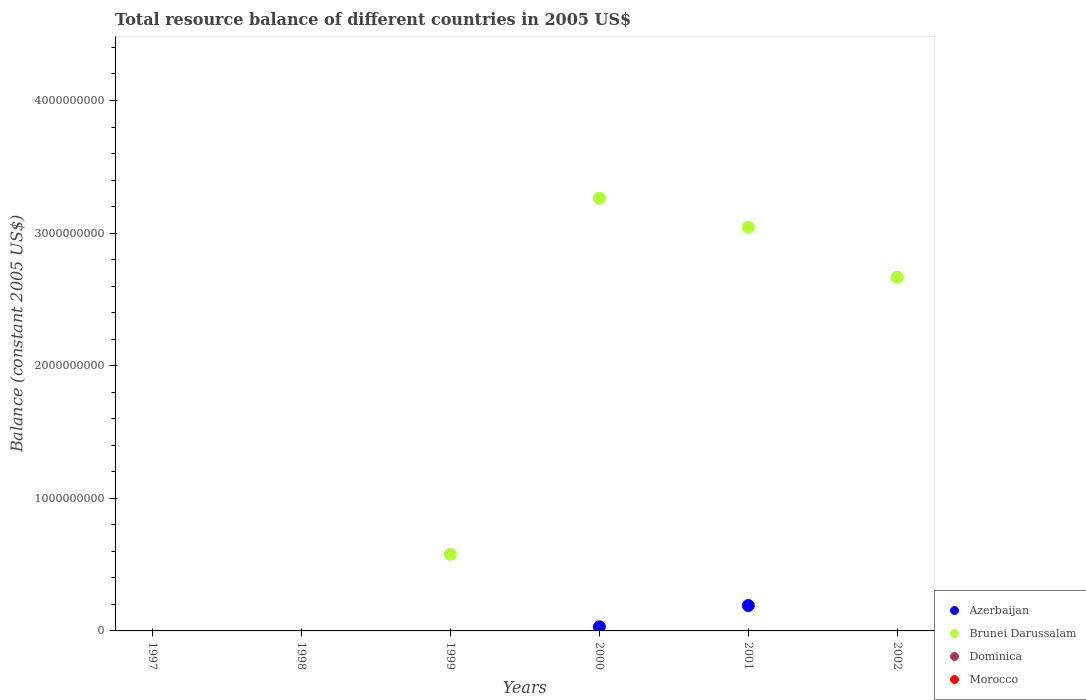How many different coloured dotlines are there?
Your answer should be compact. 2. Is the number of dotlines equal to the number of legend labels?
Provide a short and direct response. No. Across all years, what is the maximum total resource balance in Azerbaijan?
Offer a very short reply. 1.92e+08. Across all years, what is the minimum total resource balance in Azerbaijan?
Provide a short and direct response. 0. In which year was the total resource balance in Azerbaijan maximum?
Make the answer very short. 2001. What is the total total resource balance in Azerbaijan in the graph?
Keep it short and to the point. 2.23e+08. What is the difference between the total resource balance in Brunei Darussalam in 1999 and that in 2002?
Offer a terse response. -2.09e+09. What is the average total resource balance in Azerbaijan per year?
Provide a succinct answer. 3.72e+07. In how many years, is the total resource balance in Dominica greater than 3000000000 US$?
Keep it short and to the point. 0. What is the ratio of the total resource balance in Brunei Darussalam in 1999 to that in 2000?
Provide a succinct answer. 0.18. Is the total resource balance in Brunei Darussalam in 1999 less than that in 2002?
Your answer should be very brief. Yes. What is the difference between the highest and the lowest total resource balance in Brunei Darussalam?
Make the answer very short. 3.26e+09. In how many years, is the total resource balance in Morocco greater than the average total resource balance in Morocco taken over all years?
Provide a succinct answer. 0. Is it the case that in every year, the sum of the total resource balance in Azerbaijan and total resource balance in Brunei Darussalam  is greater than the total resource balance in Morocco?
Offer a very short reply. No. Is the total resource balance in Dominica strictly less than the total resource balance in Morocco over the years?
Give a very brief answer. No. How many dotlines are there?
Provide a succinct answer. 2. What is the difference between two consecutive major ticks on the Y-axis?
Provide a short and direct response. 1.00e+09. Does the graph contain any zero values?
Offer a very short reply. Yes. Does the graph contain grids?
Provide a succinct answer. No. How many legend labels are there?
Give a very brief answer. 4. What is the title of the graph?
Provide a short and direct response. Total resource balance of different countries in 2005 US$. Does "Low & middle income" appear as one of the legend labels in the graph?
Your answer should be very brief. No. What is the label or title of the Y-axis?
Ensure brevity in your answer.  Balance (constant 2005 US$). What is the Balance (constant 2005 US$) of Azerbaijan in 1997?
Your response must be concise. 0. What is the Balance (constant 2005 US$) in Dominica in 1997?
Make the answer very short. 0. What is the Balance (constant 2005 US$) in Dominica in 1998?
Give a very brief answer. 0. What is the Balance (constant 2005 US$) in Morocco in 1998?
Your answer should be very brief. 0. What is the Balance (constant 2005 US$) in Azerbaijan in 1999?
Ensure brevity in your answer.  0. What is the Balance (constant 2005 US$) in Brunei Darussalam in 1999?
Provide a succinct answer. 5.78e+08. What is the Balance (constant 2005 US$) in Dominica in 1999?
Keep it short and to the point. 0. What is the Balance (constant 2005 US$) in Azerbaijan in 2000?
Ensure brevity in your answer.  3.13e+07. What is the Balance (constant 2005 US$) of Brunei Darussalam in 2000?
Your answer should be very brief. 3.26e+09. What is the Balance (constant 2005 US$) in Azerbaijan in 2001?
Your answer should be compact. 1.92e+08. What is the Balance (constant 2005 US$) in Brunei Darussalam in 2001?
Your answer should be compact. 3.04e+09. What is the Balance (constant 2005 US$) of Azerbaijan in 2002?
Ensure brevity in your answer.  0. What is the Balance (constant 2005 US$) of Brunei Darussalam in 2002?
Your answer should be compact. 2.67e+09. What is the Balance (constant 2005 US$) in Dominica in 2002?
Your answer should be compact. 0. What is the Balance (constant 2005 US$) of Morocco in 2002?
Your answer should be very brief. 0. Across all years, what is the maximum Balance (constant 2005 US$) of Azerbaijan?
Provide a short and direct response. 1.92e+08. Across all years, what is the maximum Balance (constant 2005 US$) of Brunei Darussalam?
Your answer should be very brief. 3.26e+09. Across all years, what is the minimum Balance (constant 2005 US$) in Brunei Darussalam?
Your response must be concise. 0. What is the total Balance (constant 2005 US$) in Azerbaijan in the graph?
Keep it short and to the point. 2.23e+08. What is the total Balance (constant 2005 US$) of Brunei Darussalam in the graph?
Ensure brevity in your answer.  9.55e+09. What is the difference between the Balance (constant 2005 US$) of Brunei Darussalam in 1999 and that in 2000?
Make the answer very short. -2.68e+09. What is the difference between the Balance (constant 2005 US$) in Brunei Darussalam in 1999 and that in 2001?
Provide a succinct answer. -2.47e+09. What is the difference between the Balance (constant 2005 US$) in Brunei Darussalam in 1999 and that in 2002?
Your response must be concise. -2.09e+09. What is the difference between the Balance (constant 2005 US$) of Azerbaijan in 2000 and that in 2001?
Your answer should be very brief. -1.60e+08. What is the difference between the Balance (constant 2005 US$) of Brunei Darussalam in 2000 and that in 2001?
Give a very brief answer. 2.19e+08. What is the difference between the Balance (constant 2005 US$) in Brunei Darussalam in 2000 and that in 2002?
Your response must be concise. 5.95e+08. What is the difference between the Balance (constant 2005 US$) of Brunei Darussalam in 2001 and that in 2002?
Your answer should be compact. 3.76e+08. What is the difference between the Balance (constant 2005 US$) in Azerbaijan in 2000 and the Balance (constant 2005 US$) in Brunei Darussalam in 2001?
Keep it short and to the point. -3.01e+09. What is the difference between the Balance (constant 2005 US$) of Azerbaijan in 2000 and the Balance (constant 2005 US$) of Brunei Darussalam in 2002?
Keep it short and to the point. -2.64e+09. What is the difference between the Balance (constant 2005 US$) in Azerbaijan in 2001 and the Balance (constant 2005 US$) in Brunei Darussalam in 2002?
Your answer should be compact. -2.48e+09. What is the average Balance (constant 2005 US$) in Azerbaijan per year?
Ensure brevity in your answer.  3.72e+07. What is the average Balance (constant 2005 US$) in Brunei Darussalam per year?
Make the answer very short. 1.59e+09. What is the average Balance (constant 2005 US$) of Morocco per year?
Your answer should be very brief. 0. In the year 2000, what is the difference between the Balance (constant 2005 US$) of Azerbaijan and Balance (constant 2005 US$) of Brunei Darussalam?
Keep it short and to the point. -3.23e+09. In the year 2001, what is the difference between the Balance (constant 2005 US$) of Azerbaijan and Balance (constant 2005 US$) of Brunei Darussalam?
Offer a very short reply. -2.85e+09. What is the ratio of the Balance (constant 2005 US$) in Brunei Darussalam in 1999 to that in 2000?
Your response must be concise. 0.18. What is the ratio of the Balance (constant 2005 US$) of Brunei Darussalam in 1999 to that in 2001?
Make the answer very short. 0.19. What is the ratio of the Balance (constant 2005 US$) of Brunei Darussalam in 1999 to that in 2002?
Your answer should be very brief. 0.22. What is the ratio of the Balance (constant 2005 US$) of Azerbaijan in 2000 to that in 2001?
Give a very brief answer. 0.16. What is the ratio of the Balance (constant 2005 US$) in Brunei Darussalam in 2000 to that in 2001?
Your answer should be very brief. 1.07. What is the ratio of the Balance (constant 2005 US$) in Brunei Darussalam in 2000 to that in 2002?
Your response must be concise. 1.22. What is the ratio of the Balance (constant 2005 US$) of Brunei Darussalam in 2001 to that in 2002?
Your answer should be compact. 1.14. What is the difference between the highest and the second highest Balance (constant 2005 US$) in Brunei Darussalam?
Your response must be concise. 2.19e+08. What is the difference between the highest and the lowest Balance (constant 2005 US$) of Azerbaijan?
Ensure brevity in your answer.  1.92e+08. What is the difference between the highest and the lowest Balance (constant 2005 US$) in Brunei Darussalam?
Provide a short and direct response. 3.26e+09. 